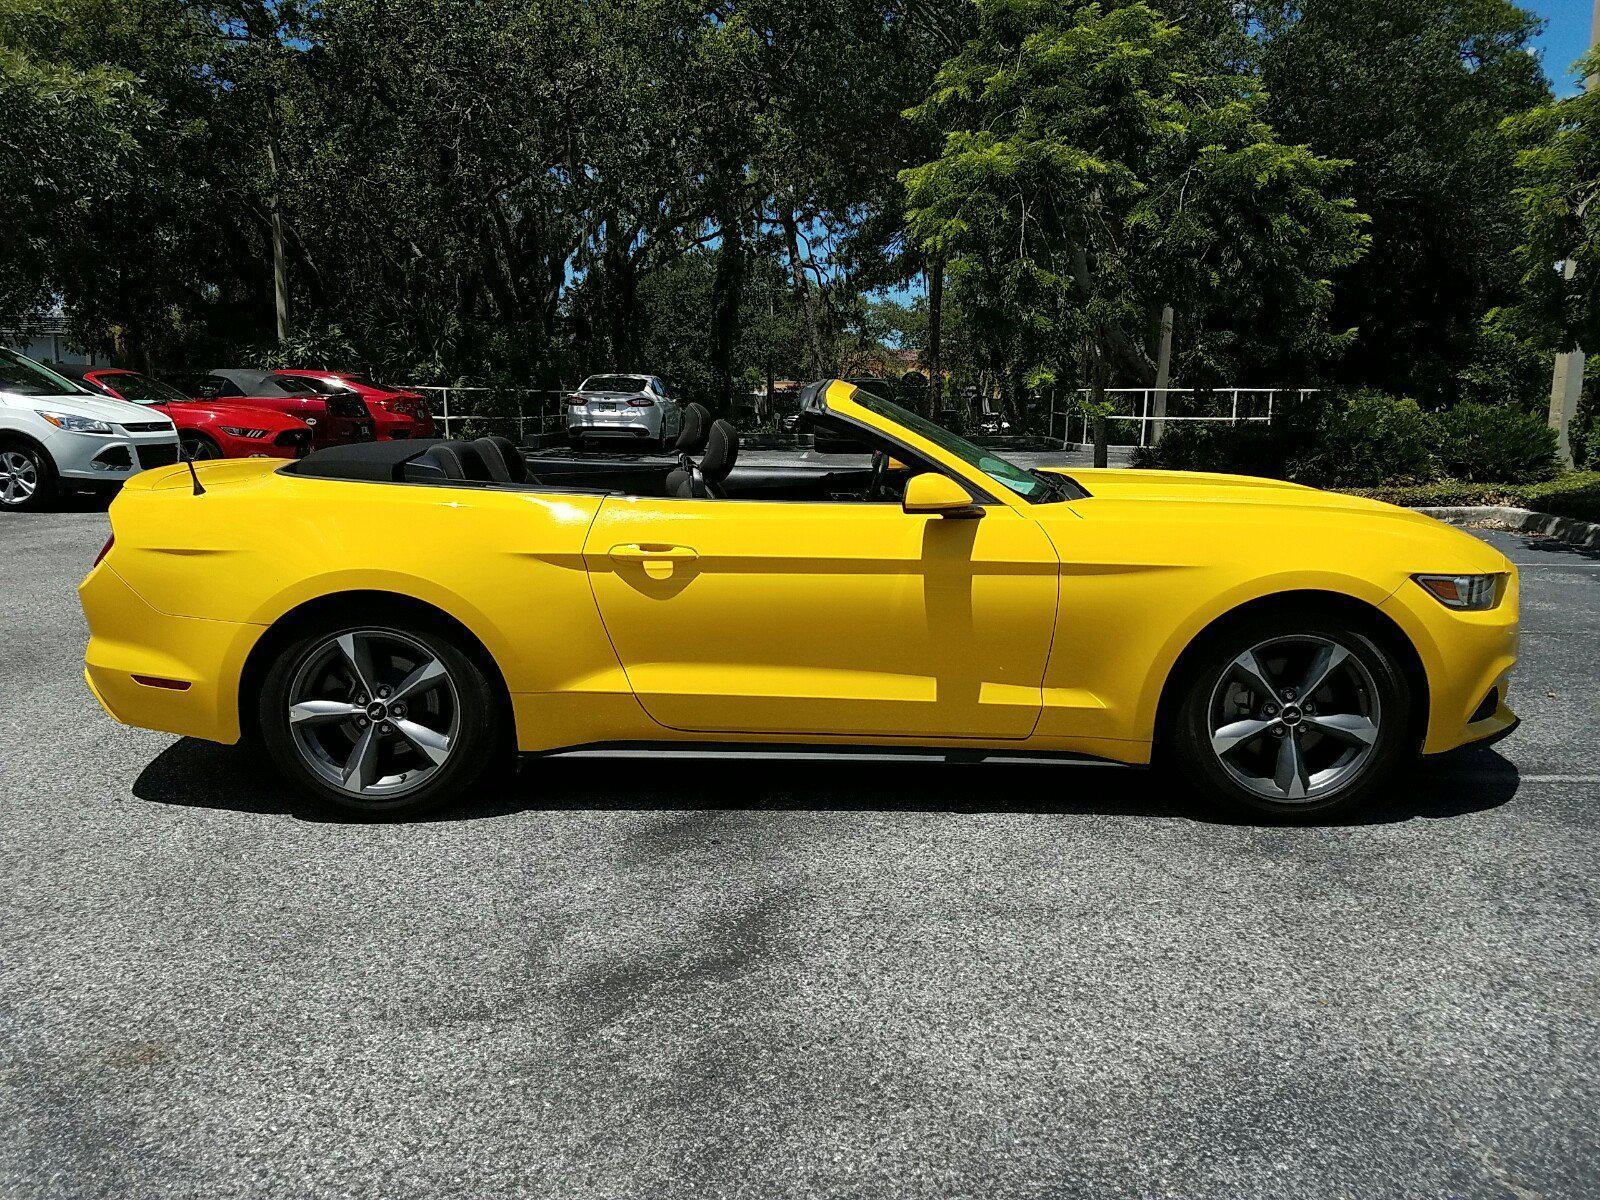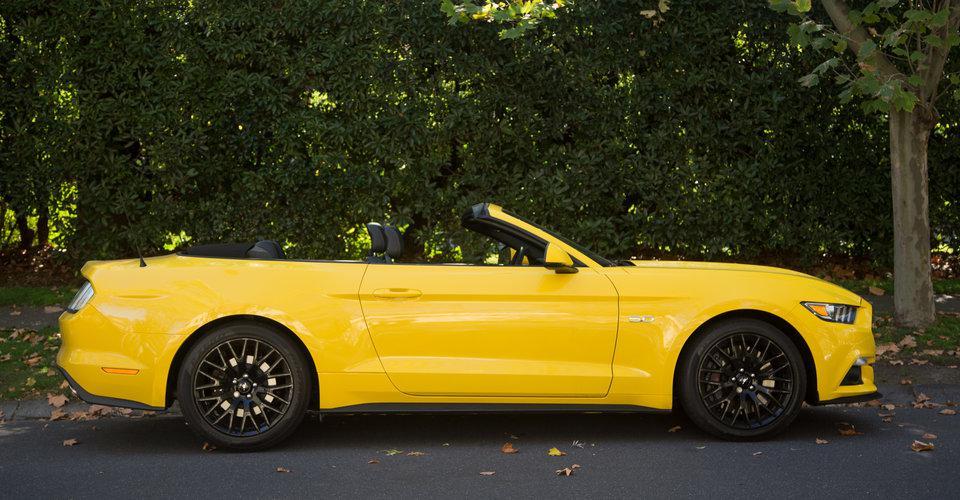The first image is the image on the left, the second image is the image on the right. For the images displayed, is the sentence "Black stripes are visible on the hood of a yellow convertible aimed rightward." factually correct? Answer yes or no. No. The first image is the image on the left, the second image is the image on the right. Analyze the images presented: Is the assertion "There are two yellow convertibles facing to the right." valid? Answer yes or no. Yes. 